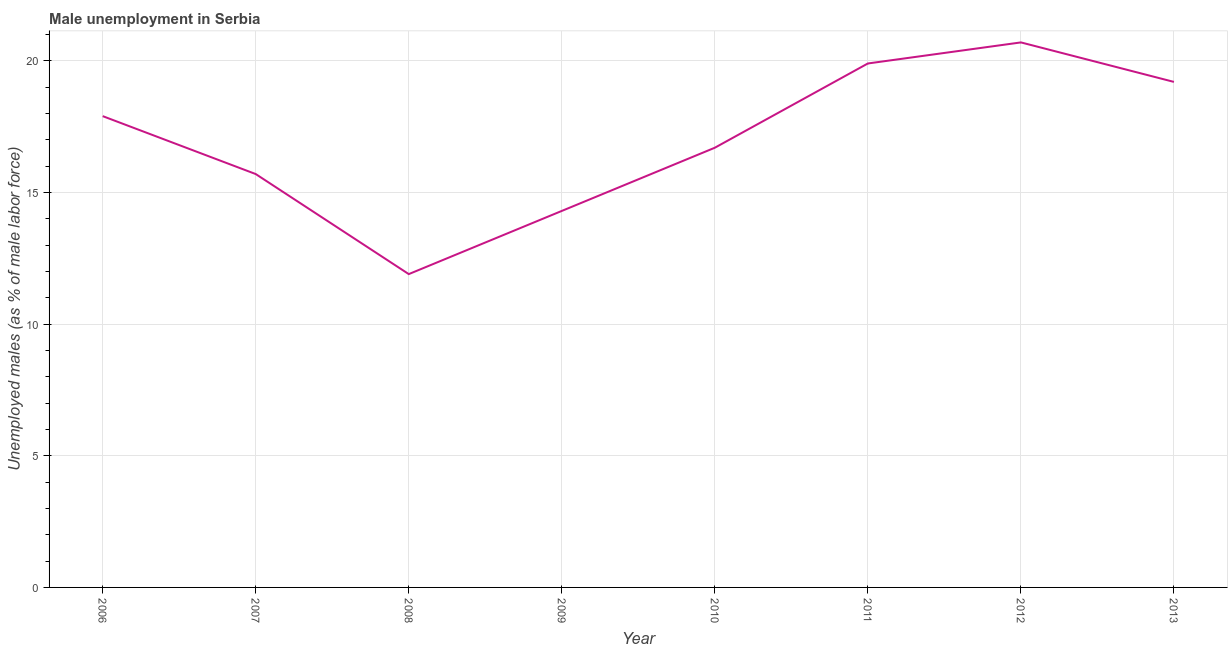What is the unemployed males population in 2010?
Keep it short and to the point. 16.7. Across all years, what is the maximum unemployed males population?
Keep it short and to the point. 20.7. Across all years, what is the minimum unemployed males population?
Make the answer very short. 11.9. In which year was the unemployed males population maximum?
Provide a succinct answer. 2012. What is the sum of the unemployed males population?
Offer a terse response. 136.3. What is the difference between the unemployed males population in 2006 and 2009?
Make the answer very short. 3.6. What is the average unemployed males population per year?
Ensure brevity in your answer.  17.04. What is the median unemployed males population?
Give a very brief answer. 17.3. Do a majority of the years between 2013 and 2008 (inclusive) have unemployed males population greater than 15 %?
Provide a succinct answer. Yes. What is the ratio of the unemployed males population in 2006 to that in 2007?
Provide a short and direct response. 1.14. Is the unemployed males population in 2007 less than that in 2008?
Ensure brevity in your answer.  No. What is the difference between the highest and the second highest unemployed males population?
Give a very brief answer. 0.8. Is the sum of the unemployed males population in 2010 and 2013 greater than the maximum unemployed males population across all years?
Keep it short and to the point. Yes. What is the difference between the highest and the lowest unemployed males population?
Your answer should be very brief. 8.8. In how many years, is the unemployed males population greater than the average unemployed males population taken over all years?
Make the answer very short. 4. Does the unemployed males population monotonically increase over the years?
Offer a terse response. No. How many lines are there?
Your response must be concise. 1. Are the values on the major ticks of Y-axis written in scientific E-notation?
Give a very brief answer. No. Does the graph contain any zero values?
Offer a very short reply. No. What is the title of the graph?
Keep it short and to the point. Male unemployment in Serbia. What is the label or title of the X-axis?
Offer a terse response. Year. What is the label or title of the Y-axis?
Ensure brevity in your answer.  Unemployed males (as % of male labor force). What is the Unemployed males (as % of male labor force) in 2006?
Provide a short and direct response. 17.9. What is the Unemployed males (as % of male labor force) of 2007?
Offer a very short reply. 15.7. What is the Unemployed males (as % of male labor force) of 2008?
Ensure brevity in your answer.  11.9. What is the Unemployed males (as % of male labor force) in 2009?
Give a very brief answer. 14.3. What is the Unemployed males (as % of male labor force) in 2010?
Keep it short and to the point. 16.7. What is the Unemployed males (as % of male labor force) in 2011?
Your answer should be very brief. 19.9. What is the Unemployed males (as % of male labor force) in 2012?
Offer a terse response. 20.7. What is the Unemployed males (as % of male labor force) of 2013?
Offer a very short reply. 19.2. What is the difference between the Unemployed males (as % of male labor force) in 2006 and 2008?
Ensure brevity in your answer.  6. What is the difference between the Unemployed males (as % of male labor force) in 2006 and 2011?
Keep it short and to the point. -2. What is the difference between the Unemployed males (as % of male labor force) in 2006 and 2012?
Your answer should be compact. -2.8. What is the difference between the Unemployed males (as % of male labor force) in 2006 and 2013?
Keep it short and to the point. -1.3. What is the difference between the Unemployed males (as % of male labor force) in 2007 and 2009?
Your answer should be compact. 1.4. What is the difference between the Unemployed males (as % of male labor force) in 2007 and 2012?
Ensure brevity in your answer.  -5. What is the difference between the Unemployed males (as % of male labor force) in 2007 and 2013?
Provide a succinct answer. -3.5. What is the difference between the Unemployed males (as % of male labor force) in 2008 and 2009?
Provide a short and direct response. -2.4. What is the difference between the Unemployed males (as % of male labor force) in 2008 and 2010?
Provide a short and direct response. -4.8. What is the difference between the Unemployed males (as % of male labor force) in 2008 and 2011?
Your answer should be compact. -8. What is the difference between the Unemployed males (as % of male labor force) in 2008 and 2012?
Make the answer very short. -8.8. What is the difference between the Unemployed males (as % of male labor force) in 2008 and 2013?
Make the answer very short. -7.3. What is the difference between the Unemployed males (as % of male labor force) in 2010 and 2011?
Provide a short and direct response. -3.2. What is the difference between the Unemployed males (as % of male labor force) in 2010 and 2013?
Offer a very short reply. -2.5. What is the difference between the Unemployed males (as % of male labor force) in 2011 and 2013?
Your answer should be very brief. 0.7. What is the ratio of the Unemployed males (as % of male labor force) in 2006 to that in 2007?
Keep it short and to the point. 1.14. What is the ratio of the Unemployed males (as % of male labor force) in 2006 to that in 2008?
Offer a very short reply. 1.5. What is the ratio of the Unemployed males (as % of male labor force) in 2006 to that in 2009?
Your answer should be compact. 1.25. What is the ratio of the Unemployed males (as % of male labor force) in 2006 to that in 2010?
Your answer should be very brief. 1.07. What is the ratio of the Unemployed males (as % of male labor force) in 2006 to that in 2011?
Provide a succinct answer. 0.9. What is the ratio of the Unemployed males (as % of male labor force) in 2006 to that in 2012?
Offer a very short reply. 0.86. What is the ratio of the Unemployed males (as % of male labor force) in 2006 to that in 2013?
Provide a succinct answer. 0.93. What is the ratio of the Unemployed males (as % of male labor force) in 2007 to that in 2008?
Offer a terse response. 1.32. What is the ratio of the Unemployed males (as % of male labor force) in 2007 to that in 2009?
Make the answer very short. 1.1. What is the ratio of the Unemployed males (as % of male labor force) in 2007 to that in 2011?
Your answer should be very brief. 0.79. What is the ratio of the Unemployed males (as % of male labor force) in 2007 to that in 2012?
Give a very brief answer. 0.76. What is the ratio of the Unemployed males (as % of male labor force) in 2007 to that in 2013?
Provide a short and direct response. 0.82. What is the ratio of the Unemployed males (as % of male labor force) in 2008 to that in 2009?
Offer a very short reply. 0.83. What is the ratio of the Unemployed males (as % of male labor force) in 2008 to that in 2010?
Your answer should be very brief. 0.71. What is the ratio of the Unemployed males (as % of male labor force) in 2008 to that in 2011?
Make the answer very short. 0.6. What is the ratio of the Unemployed males (as % of male labor force) in 2008 to that in 2012?
Your answer should be compact. 0.57. What is the ratio of the Unemployed males (as % of male labor force) in 2008 to that in 2013?
Offer a very short reply. 0.62. What is the ratio of the Unemployed males (as % of male labor force) in 2009 to that in 2010?
Ensure brevity in your answer.  0.86. What is the ratio of the Unemployed males (as % of male labor force) in 2009 to that in 2011?
Offer a very short reply. 0.72. What is the ratio of the Unemployed males (as % of male labor force) in 2009 to that in 2012?
Keep it short and to the point. 0.69. What is the ratio of the Unemployed males (as % of male labor force) in 2009 to that in 2013?
Keep it short and to the point. 0.74. What is the ratio of the Unemployed males (as % of male labor force) in 2010 to that in 2011?
Ensure brevity in your answer.  0.84. What is the ratio of the Unemployed males (as % of male labor force) in 2010 to that in 2012?
Your answer should be compact. 0.81. What is the ratio of the Unemployed males (as % of male labor force) in 2010 to that in 2013?
Make the answer very short. 0.87. What is the ratio of the Unemployed males (as % of male labor force) in 2011 to that in 2012?
Your answer should be very brief. 0.96. What is the ratio of the Unemployed males (as % of male labor force) in 2011 to that in 2013?
Keep it short and to the point. 1.04. What is the ratio of the Unemployed males (as % of male labor force) in 2012 to that in 2013?
Keep it short and to the point. 1.08. 